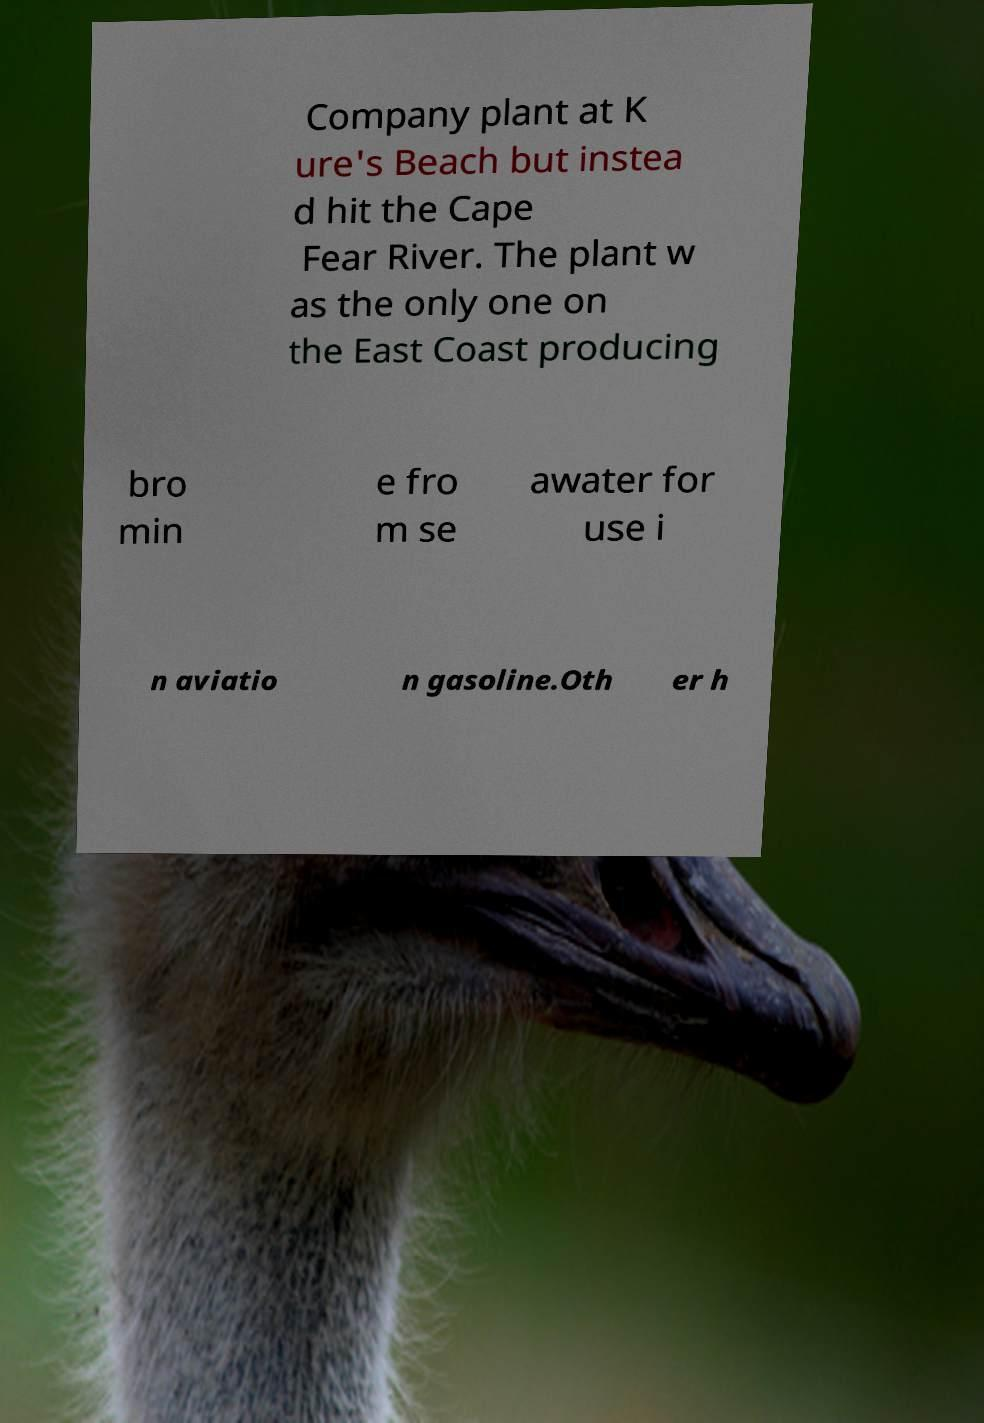There's text embedded in this image that I need extracted. Can you transcribe it verbatim? Company plant at K ure's Beach but instea d hit the Cape Fear River. The plant w as the only one on the East Coast producing bro min e fro m se awater for use i n aviatio n gasoline.Oth er h 